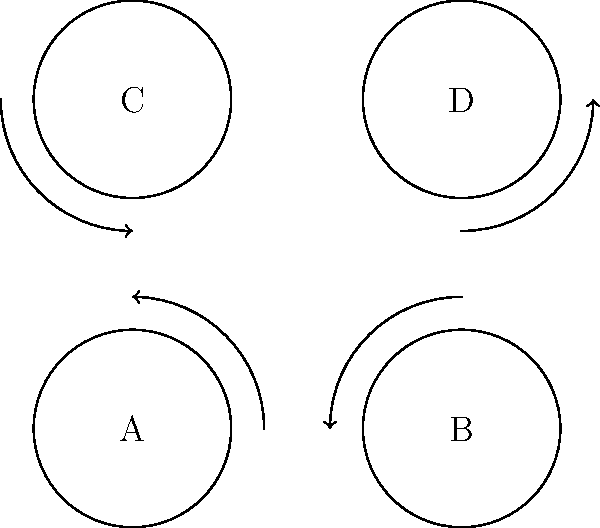A banking chatbot has four response options (A, B, C, D) that can be rearranged to optimize user experience. The diagram shows a cyclic permutation of these options. How many unique arrangements (including the original) can be created using only this cyclic permutation? Let's approach this step-by-step:

1) The given permutation is a cyclic permutation of order 4, which can be written as $(A B C D)$ in cycle notation.

2) To find the number of unique arrangements, we need to determine the order of this permutation in the permutation group $S_4$.

3) The order of a cyclic permutation is equal to its length. In this case, the length is 4.

4) This means that applying the permutation 4 times will return us to the original arrangement:
   $(A B C D)^1 = (B C D A)$
   $(A B C D)^2 = (C D A B)$
   $(A B C D)^3 = (D A B C)$
   $(A B C D)^4 = (A B C D)$ (back to the original)

5) Each of these 4 arrangements is unique.

Therefore, there are 4 unique arrangements that can be created using only this cyclic permutation.
Answer: 4 